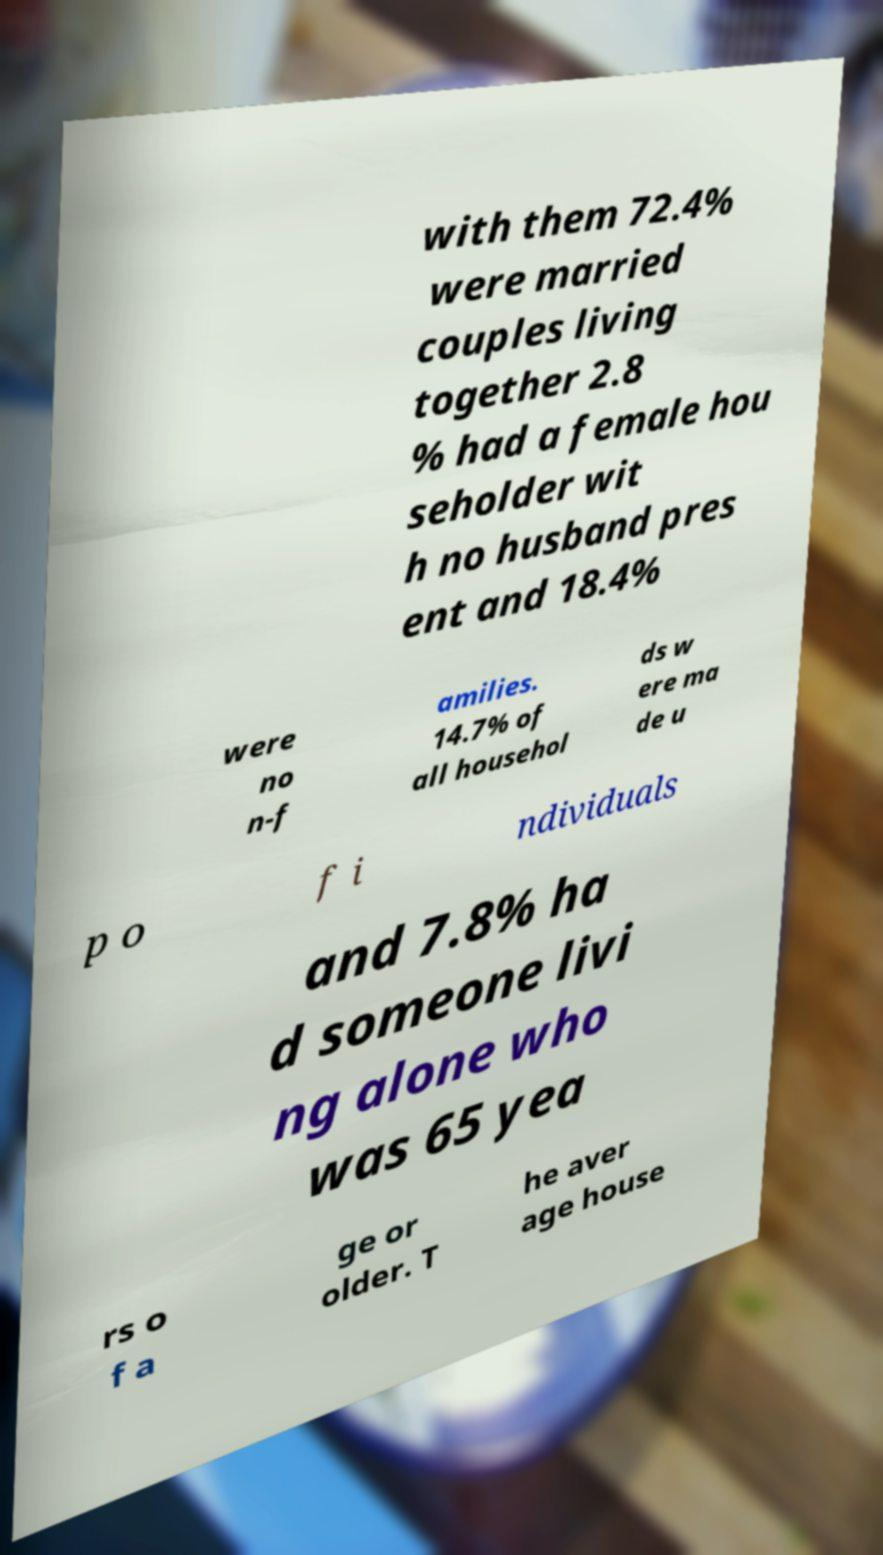For documentation purposes, I need the text within this image transcribed. Could you provide that? with them 72.4% were married couples living together 2.8 % had a female hou seholder wit h no husband pres ent and 18.4% were no n-f amilies. 14.7% of all househol ds w ere ma de u p o f i ndividuals and 7.8% ha d someone livi ng alone who was 65 yea rs o f a ge or older. T he aver age house 